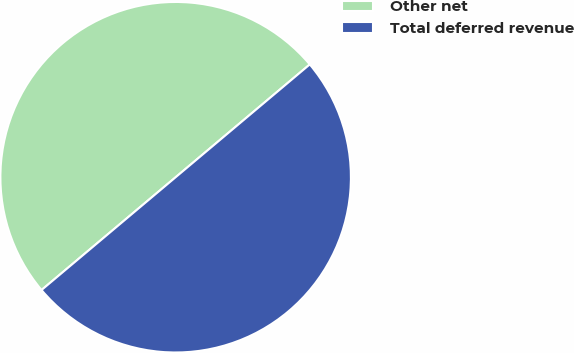Convert chart. <chart><loc_0><loc_0><loc_500><loc_500><pie_chart><fcel>Other net<fcel>Total deferred revenue<nl><fcel>50.0%<fcel>50.0%<nl></chart> 